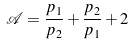<formula> <loc_0><loc_0><loc_500><loc_500>\mathcal { A } = \frac { p _ { 1 } } { p _ { 2 } } + \frac { p _ { 2 } } { p _ { 1 } } + 2</formula> 